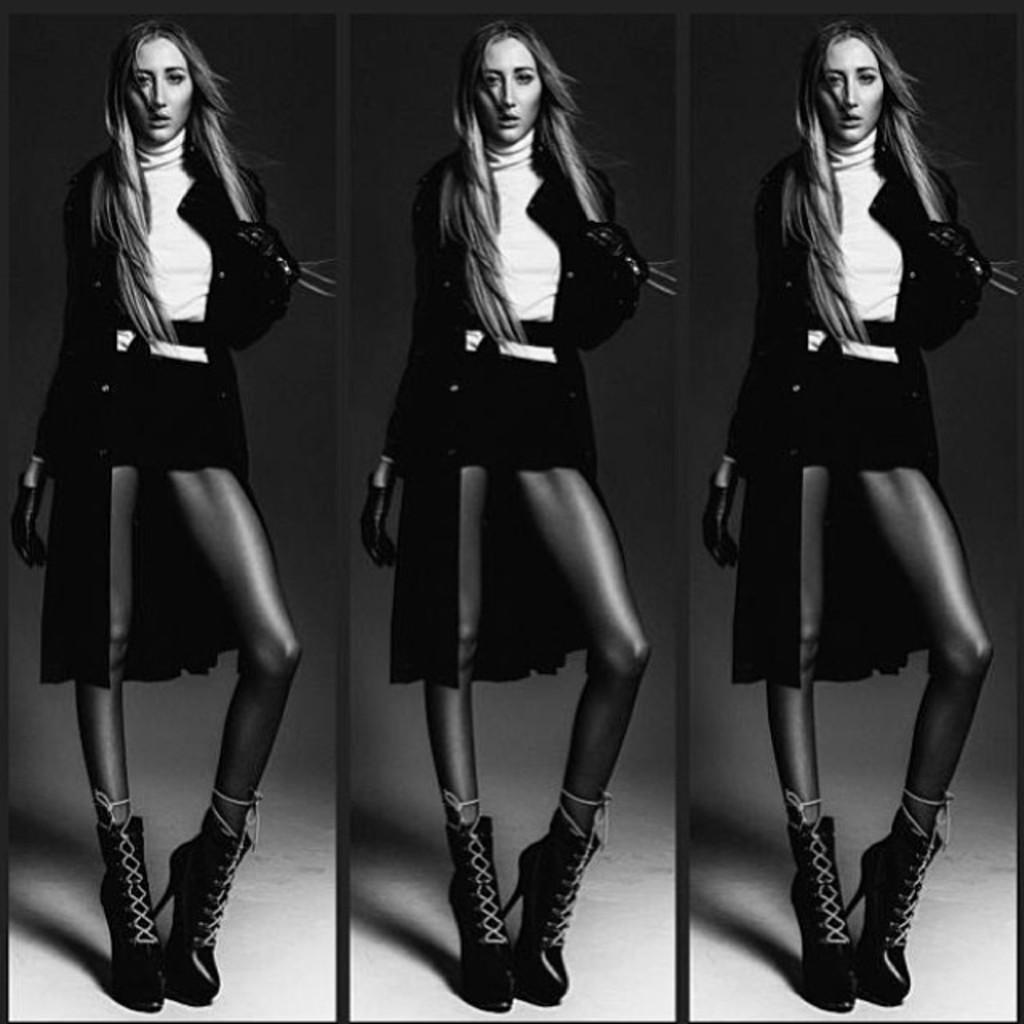What is the main subject of the image? The image contains a collage of pictures. Can you describe one of the pictures in the collage? There is a black and white picture of a woman in the collage. What is the woman in the picture doing? The woman in the picture is standing on the floor. What type of needle is the woman holding in the picture? There is no needle present in the picture; the woman is simply standing on the floor. 